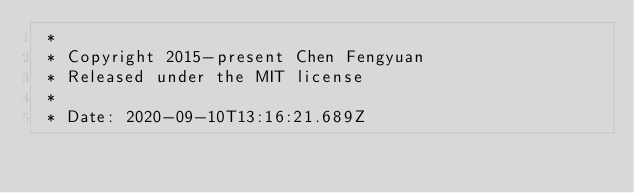Convert code to text. <code><loc_0><loc_0><loc_500><loc_500><_CSS_> *
 * Copyright 2015-present Chen Fengyuan
 * Released under the MIT license
 *
 * Date: 2020-09-10T13:16:21.689Z</code> 